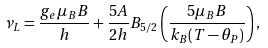Convert formula to latex. <formula><loc_0><loc_0><loc_500><loc_500>\nu _ { L } = \frac { g _ { e } \mu _ { B } B } { h } + \frac { 5 A } { 2 h } B _ { 5 / 2 } \left ( \frac { 5 \mu _ { B } B } { k _ { B } ( T - \theta _ { P } ) } \right ) ,</formula> 